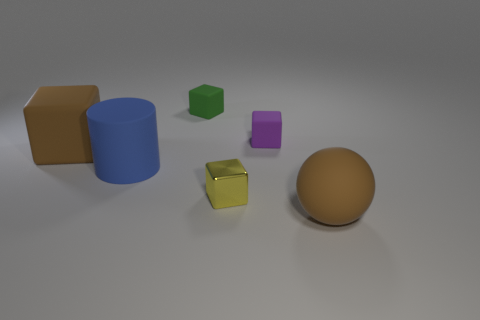Are there any other things that are the same material as the yellow cube?
Your answer should be very brief. No. Are there fewer tiny yellow things in front of the brown sphere than metal cubes to the right of the blue rubber cylinder?
Your answer should be compact. Yes. What material is the block that is both on the right side of the large blue matte cylinder and in front of the purple matte block?
Your answer should be compact. Metal. What is the shape of the brown rubber object behind the big thing right of the yellow metallic thing?
Your response must be concise. Cube. Is the big rubber sphere the same color as the cylinder?
Provide a succinct answer. No. How many cyan things are either rubber balls or big matte objects?
Offer a very short reply. 0. Are there any rubber cubes in front of the brown ball?
Provide a short and direct response. No. The sphere is what size?
Make the answer very short. Large. The green rubber thing that is the same shape as the small shiny thing is what size?
Give a very brief answer. Small. There is a brown cube that is on the left side of the small yellow block; what number of objects are in front of it?
Your response must be concise. 3. 